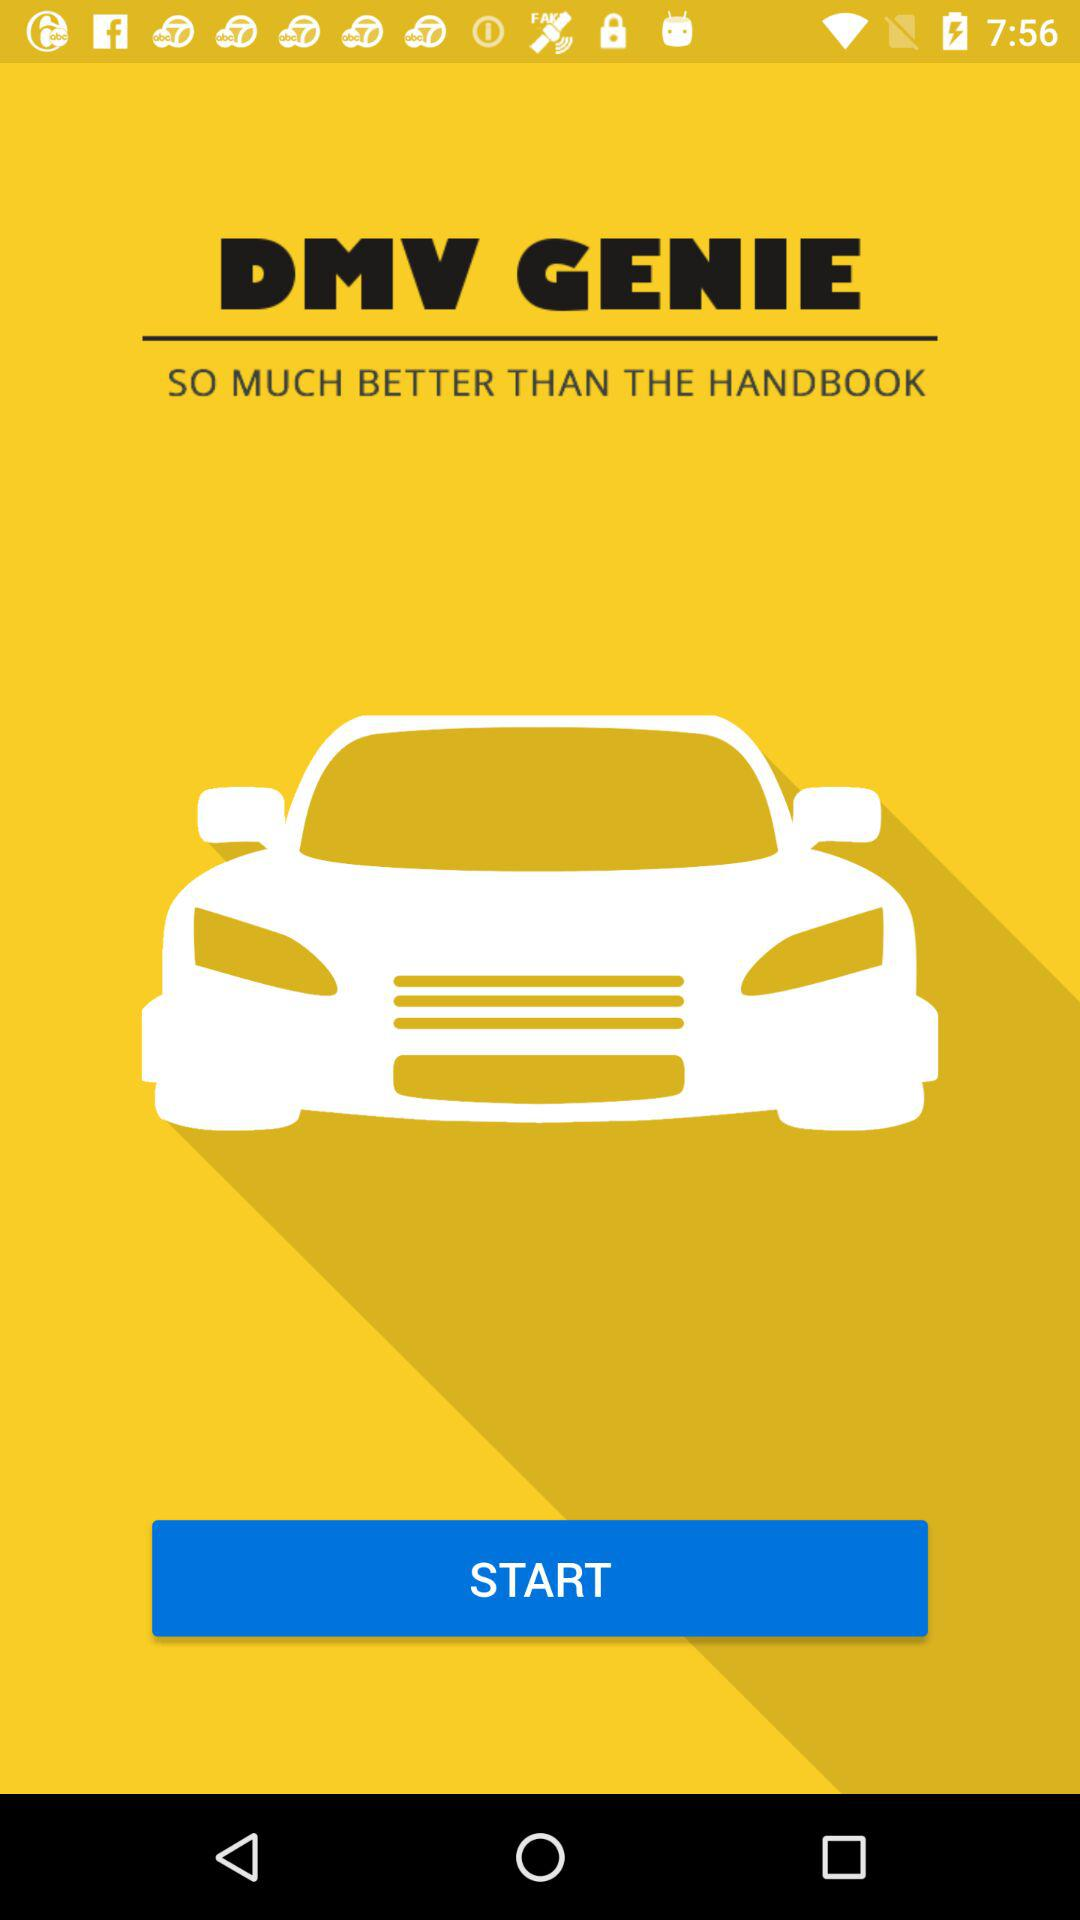What is the application name? The application name is "DMV GENIE". 